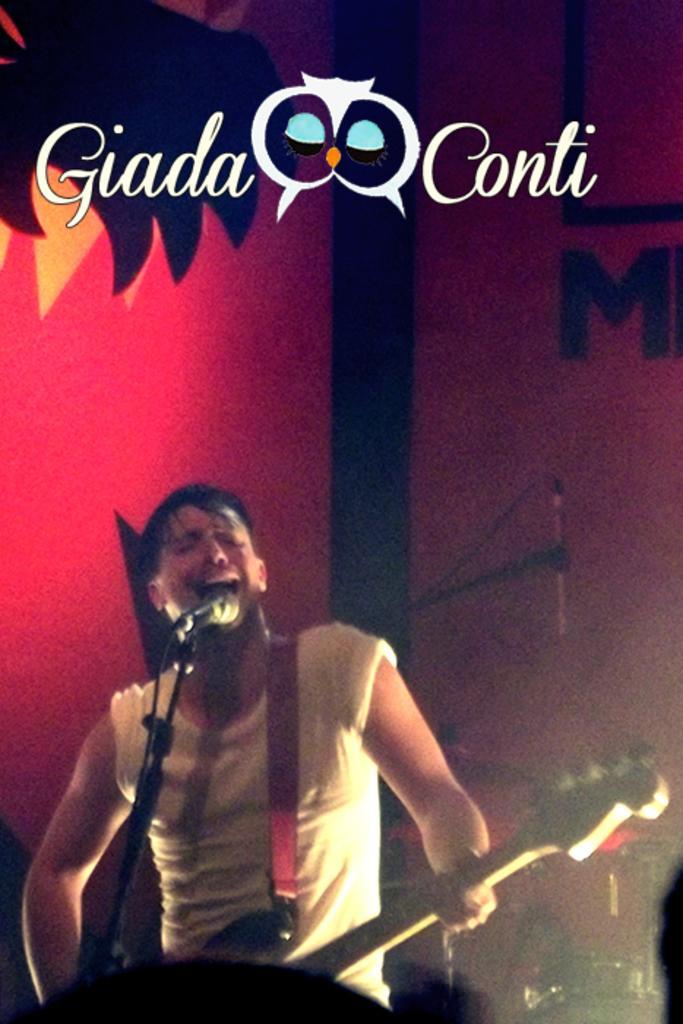How would you summarize this image in a sentence or two? In this image there is a person standing on the stage and playing guitar, behind him there is a wall with paintings and some text at the top of image. 